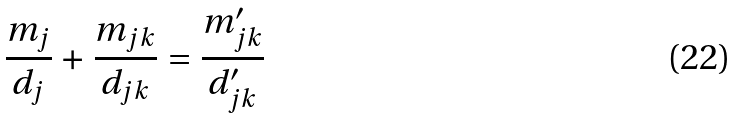<formula> <loc_0><loc_0><loc_500><loc_500>\frac { m _ { j } } { d _ { j } } + \frac { m _ { j k } } { d _ { j k } } = \frac { m ^ { \prime } _ { j k } } { d ^ { \prime } _ { j k } }</formula> 